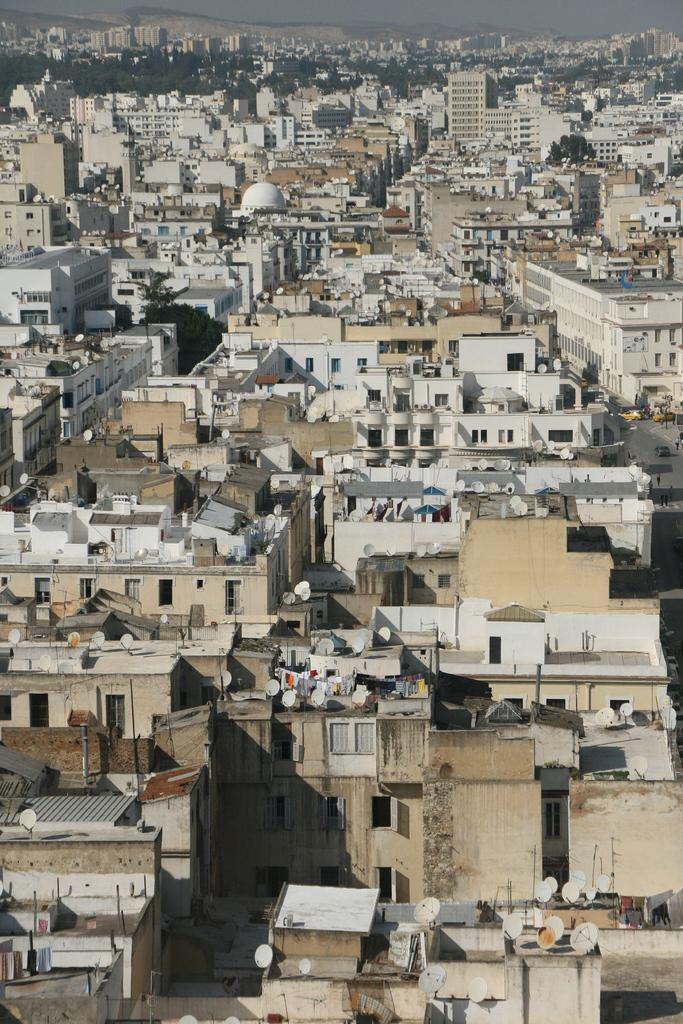What structures are present in the image? There are buildings in the image. What feature can be seen on top of the buildings? There are antennas on the buildings. What type of vegetation is visible behind the buildings? There are trees visible behind the buildings. How many ants can be seen climbing the buildings in the image? There are no ants present in the image; it features buildings with antennas and trees in the background. What type of kite is flying in the image? There is no kite present in the image; it only shows buildings, antennas, and trees. 